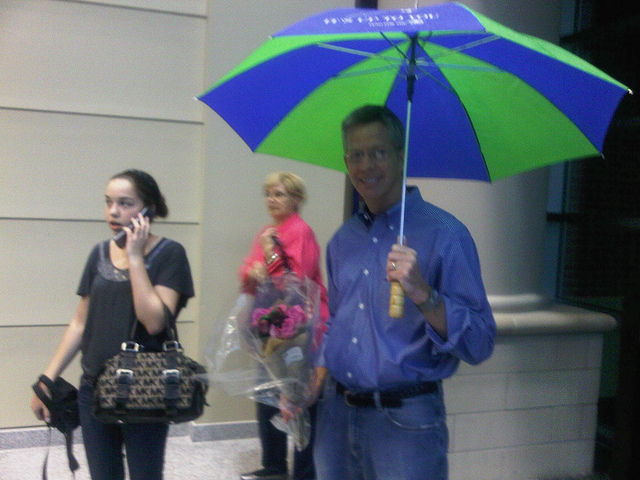<image>Which person is smoking? There is no person smoking in the image. What type of umbrella is she holding? There is no umbrella in the image. However, it might be a rain umbrella. Which person is smoking? No one is smoking in the image. What type of umbrella is she holding? I am not sure what type of umbrella is she holding. It can be an open umbrella, a clear one, a blue and green one, or a plastic umbrella. 